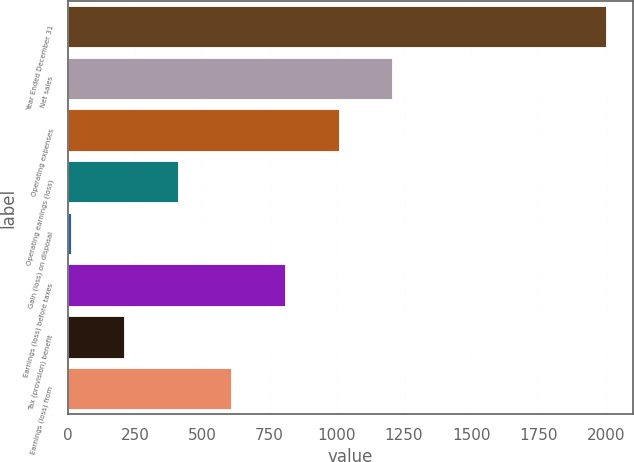Convert chart. <chart><loc_0><loc_0><loc_500><loc_500><bar_chart><fcel>Year Ended December 31<fcel>Net sales<fcel>Operating expenses<fcel>Operating earnings (loss)<fcel>Gain (loss) on disposal<fcel>Earnings (loss) before taxes<fcel>Tax (provision) benefit<fcel>Earnings (loss) from<nl><fcel>2003<fcel>1205.8<fcel>1006.5<fcel>408.6<fcel>10<fcel>807.2<fcel>209.3<fcel>607.9<nl></chart> 